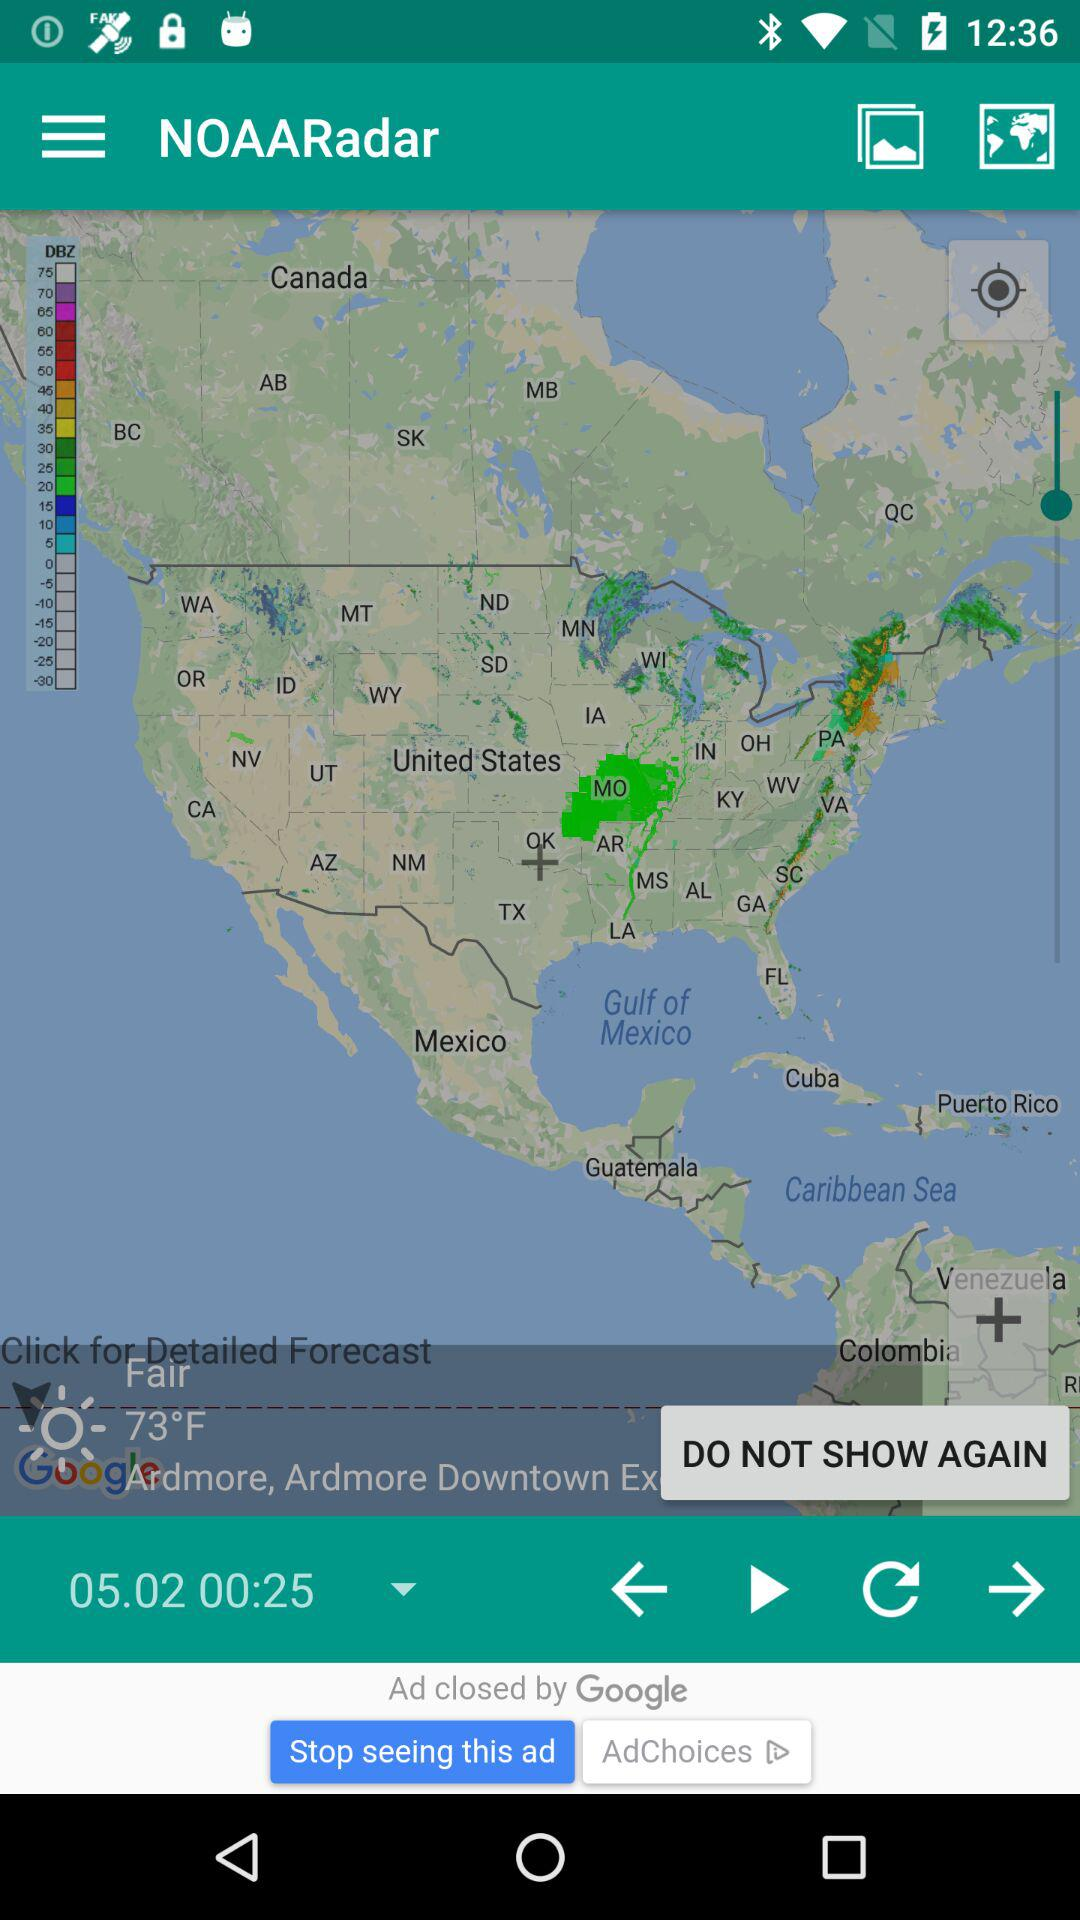What is the temperature? The temperature is 73°F. 